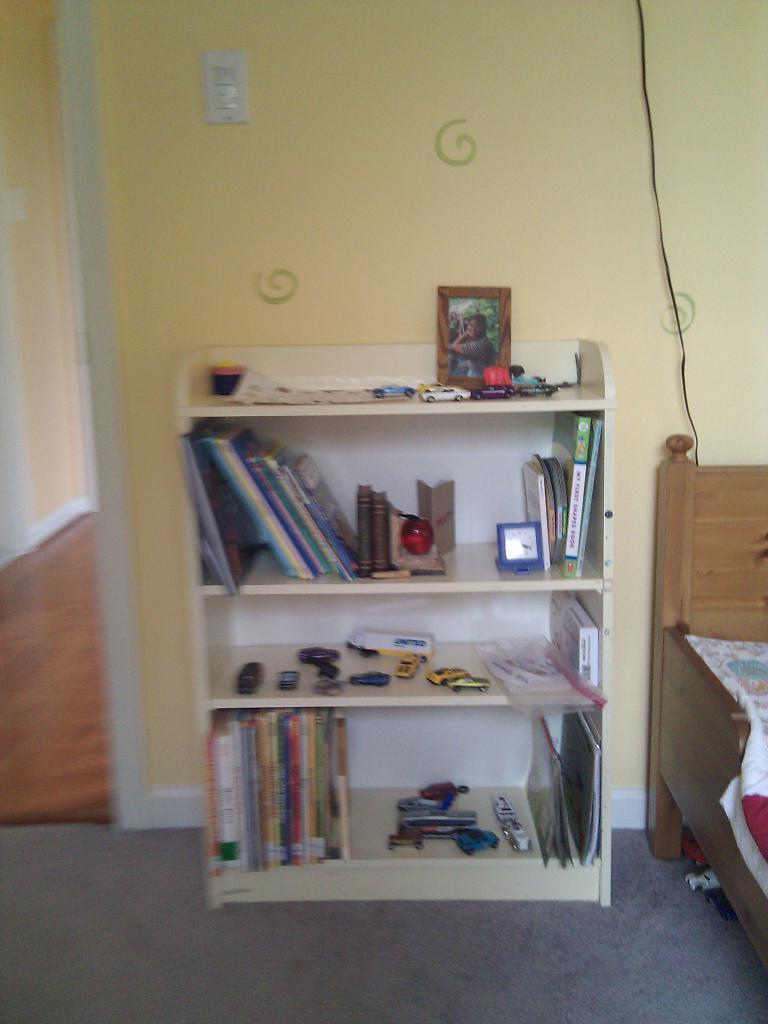Please provide a concise description of this image. In the center we can see shelf,in shelf there is a book,clock,phone,toys and tools. On the right there is a bed,in the background we can see wall. 